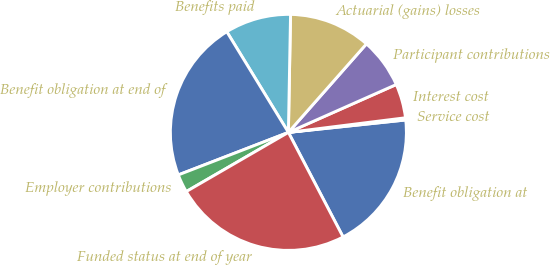Convert chart. <chart><loc_0><loc_0><loc_500><loc_500><pie_chart><fcel>Benefit obligation at<fcel>Service cost<fcel>Interest cost<fcel>Participant contributions<fcel>Actuarial (gains) losses<fcel>Benefits paid<fcel>Benefit obligation at end of<fcel>Employer contributions<fcel>Funded status at end of year<nl><fcel>19.01%<fcel>0.3%<fcel>4.67%<fcel>6.85%<fcel>11.21%<fcel>9.03%<fcel>22.13%<fcel>2.49%<fcel>24.31%<nl></chart> 